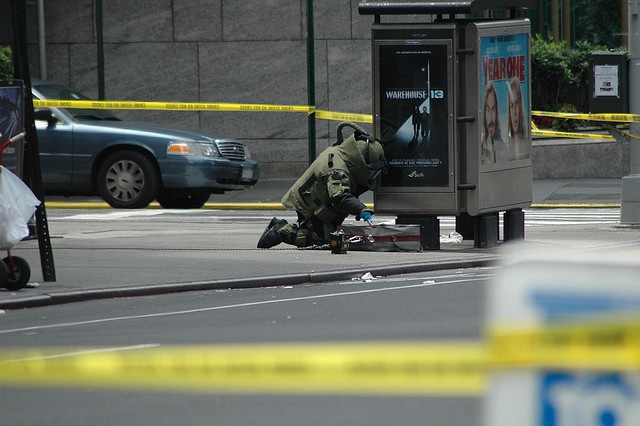Describe the objects in this image and their specific colors. I can see car in black, gray, blue, and darkblue tones, people in black, gray, and darkgray tones, and suitcase in black, gray, and darkgray tones in this image. 